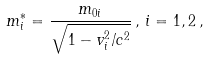<formula> <loc_0><loc_0><loc_500><loc_500>m _ { i } ^ { * } = \frac { m _ { 0 i } } { \sqrt { 1 - v _ { i } ^ { 2 } / c ^ { 2 } } } \, , \, i = 1 , 2 \, ,</formula> 